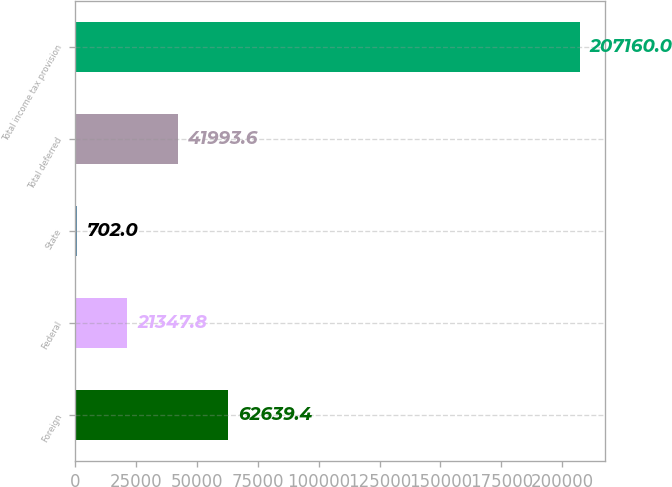Convert chart. <chart><loc_0><loc_0><loc_500><loc_500><bar_chart><fcel>Foreign<fcel>Federal<fcel>State<fcel>Total deferred<fcel>Total income tax provision<nl><fcel>62639.4<fcel>21347.8<fcel>702<fcel>41993.6<fcel>207160<nl></chart> 